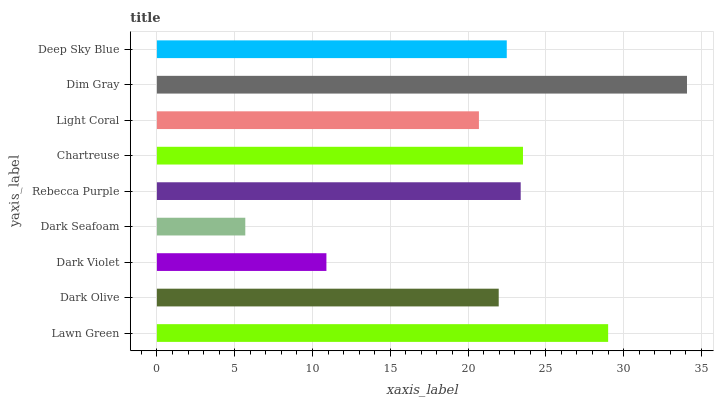Is Dark Seafoam the minimum?
Answer yes or no. Yes. Is Dim Gray the maximum?
Answer yes or no. Yes. Is Dark Olive the minimum?
Answer yes or no. No. Is Dark Olive the maximum?
Answer yes or no. No. Is Lawn Green greater than Dark Olive?
Answer yes or no. Yes. Is Dark Olive less than Lawn Green?
Answer yes or no. Yes. Is Dark Olive greater than Lawn Green?
Answer yes or no. No. Is Lawn Green less than Dark Olive?
Answer yes or no. No. Is Deep Sky Blue the high median?
Answer yes or no. Yes. Is Deep Sky Blue the low median?
Answer yes or no. Yes. Is Dim Gray the high median?
Answer yes or no. No. Is Chartreuse the low median?
Answer yes or no. No. 